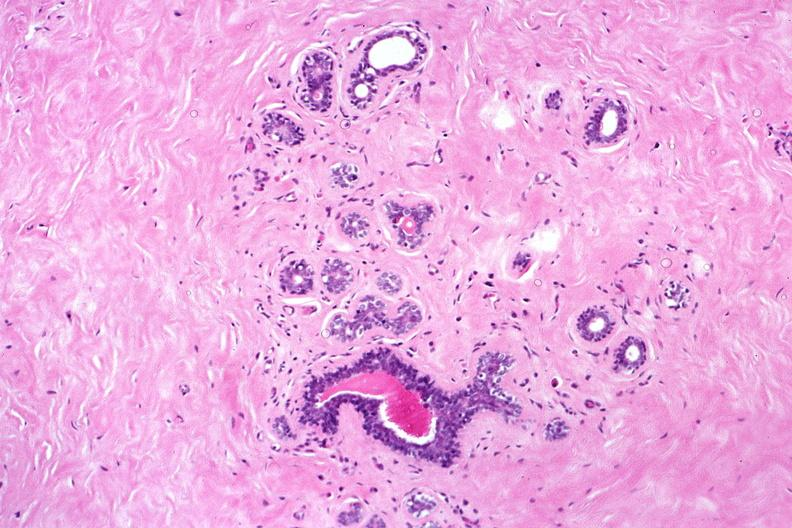does this image show normal breast?
Answer the question using a single word or phrase. Yes 